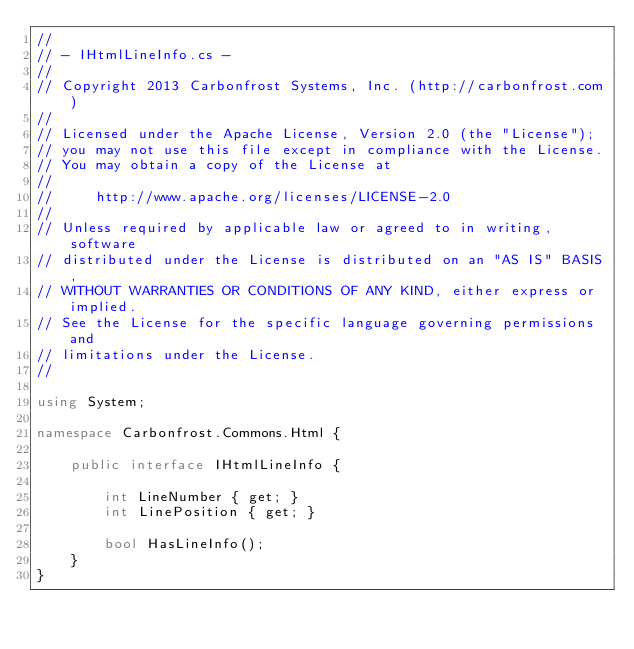<code> <loc_0><loc_0><loc_500><loc_500><_C#_>//
// - IHtmlLineInfo.cs -
//
// Copyright 2013 Carbonfrost Systems, Inc. (http://carbonfrost.com)
//
// Licensed under the Apache License, Version 2.0 (the "License");
// you may not use this file except in compliance with the License.
// You may obtain a copy of the License at
//
//     http://www.apache.org/licenses/LICENSE-2.0
//
// Unless required by applicable law or agreed to in writing, software
// distributed under the License is distributed on an "AS IS" BASIS,
// WITHOUT WARRANTIES OR CONDITIONS OF ANY KIND, either express or implied.
// See the License for the specific language governing permissions and
// limitations under the License.
//

using System;

namespace Carbonfrost.Commons.Html {

    public interface IHtmlLineInfo {

        int LineNumber { get; }
        int LinePosition { get; }

        bool HasLineInfo();
    }
}
</code> 